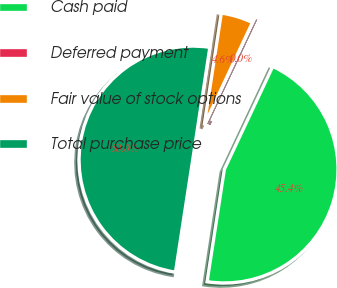<chart> <loc_0><loc_0><loc_500><loc_500><pie_chart><fcel>Cash paid<fcel>Deferred payment<fcel>Fair value of stock options<fcel>Total purchase price<nl><fcel>45.43%<fcel>0.02%<fcel>4.57%<fcel>49.98%<nl></chart> 